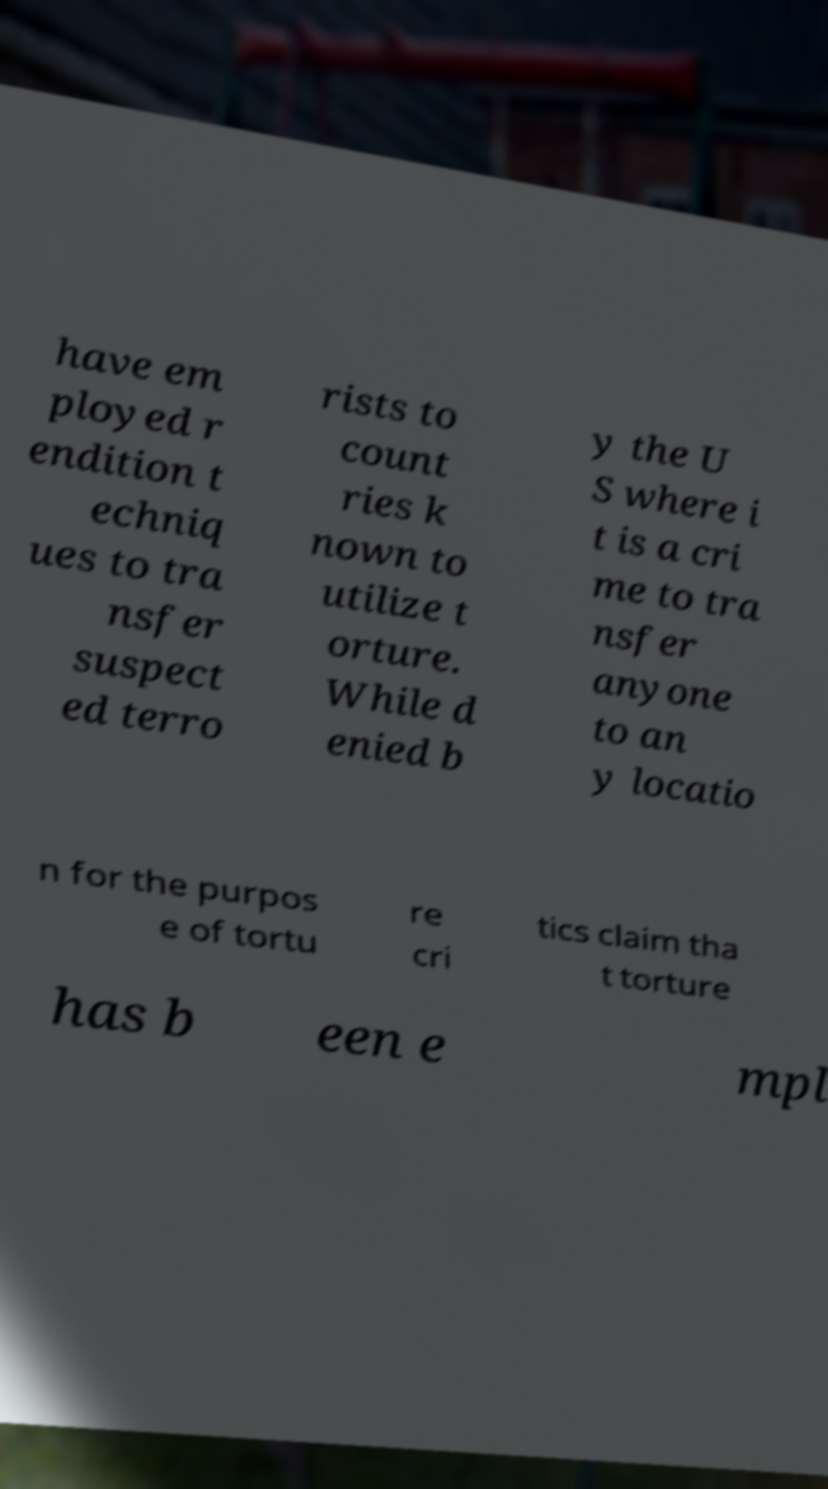Please read and relay the text visible in this image. What does it say? have em ployed r endition t echniq ues to tra nsfer suspect ed terro rists to count ries k nown to utilize t orture. While d enied b y the U S where i t is a cri me to tra nsfer anyone to an y locatio n for the purpos e of tortu re cri tics claim tha t torture has b een e mpl 